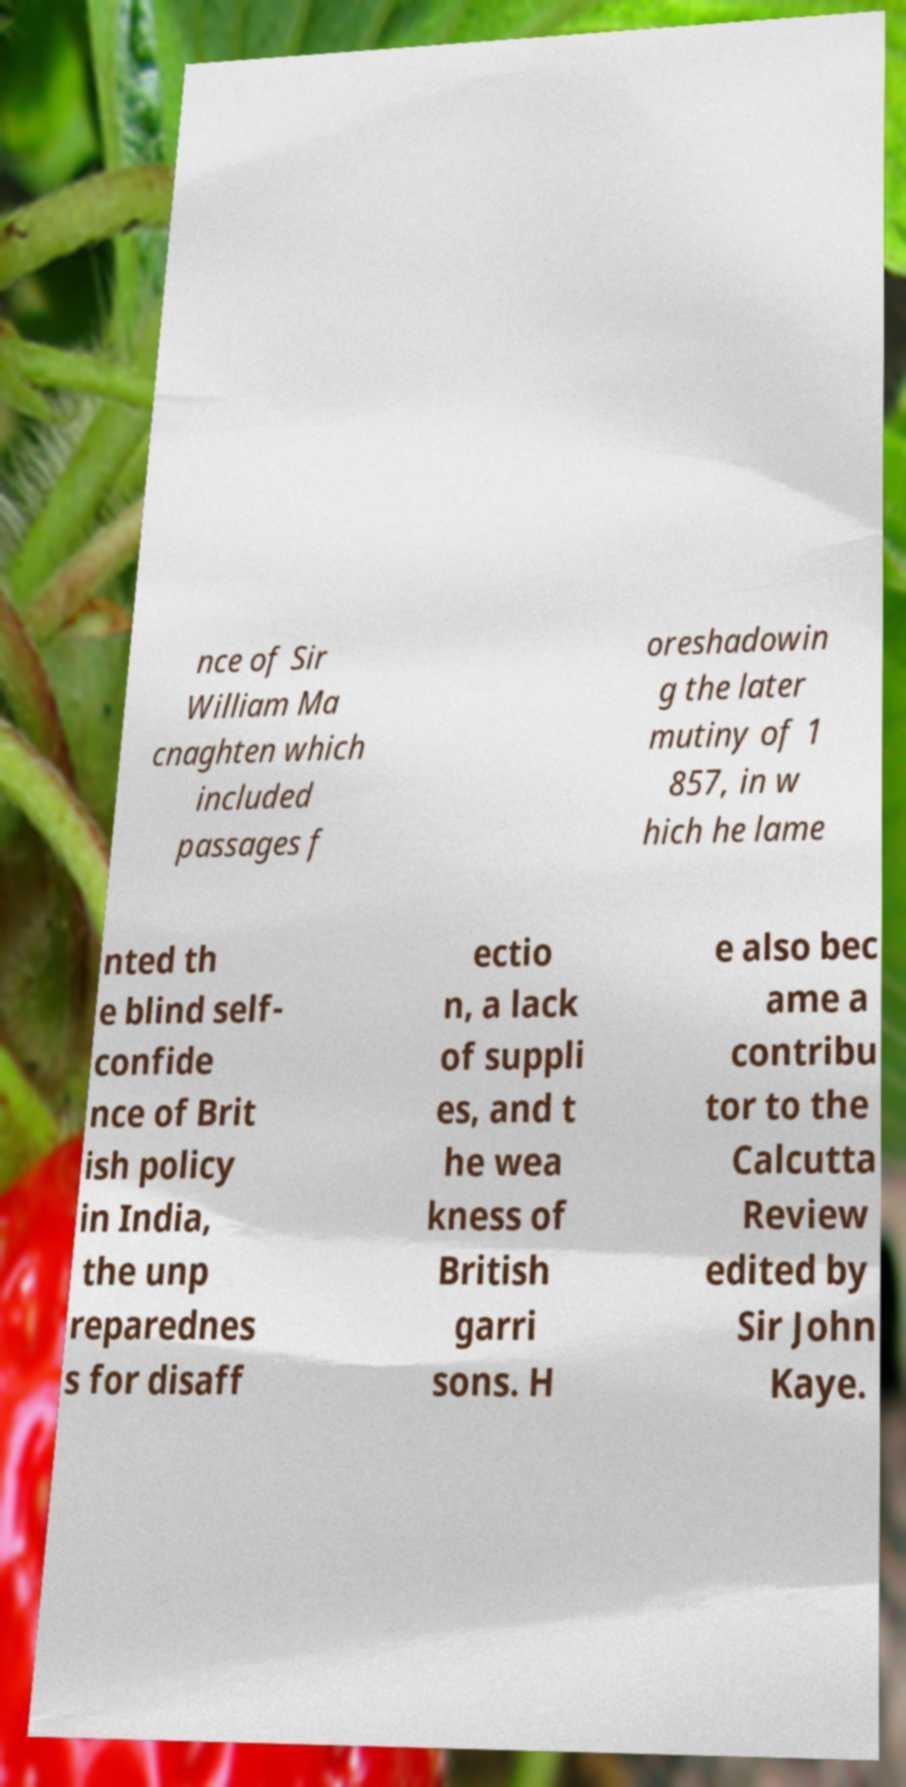There's text embedded in this image that I need extracted. Can you transcribe it verbatim? nce of Sir William Ma cnaghten which included passages f oreshadowin g the later mutiny of 1 857, in w hich he lame nted th e blind self- confide nce of Brit ish policy in India, the unp reparednes s for disaff ectio n, a lack of suppli es, and t he wea kness of British garri sons. H e also bec ame a contribu tor to the Calcutta Review edited by Sir John Kaye. 